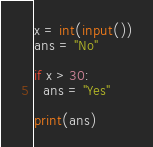Convert code to text. <code><loc_0><loc_0><loc_500><loc_500><_Python_>x = int(input())
ans = "No"

if x > 30:
  ans = "Yes"
  
print(ans)</code> 